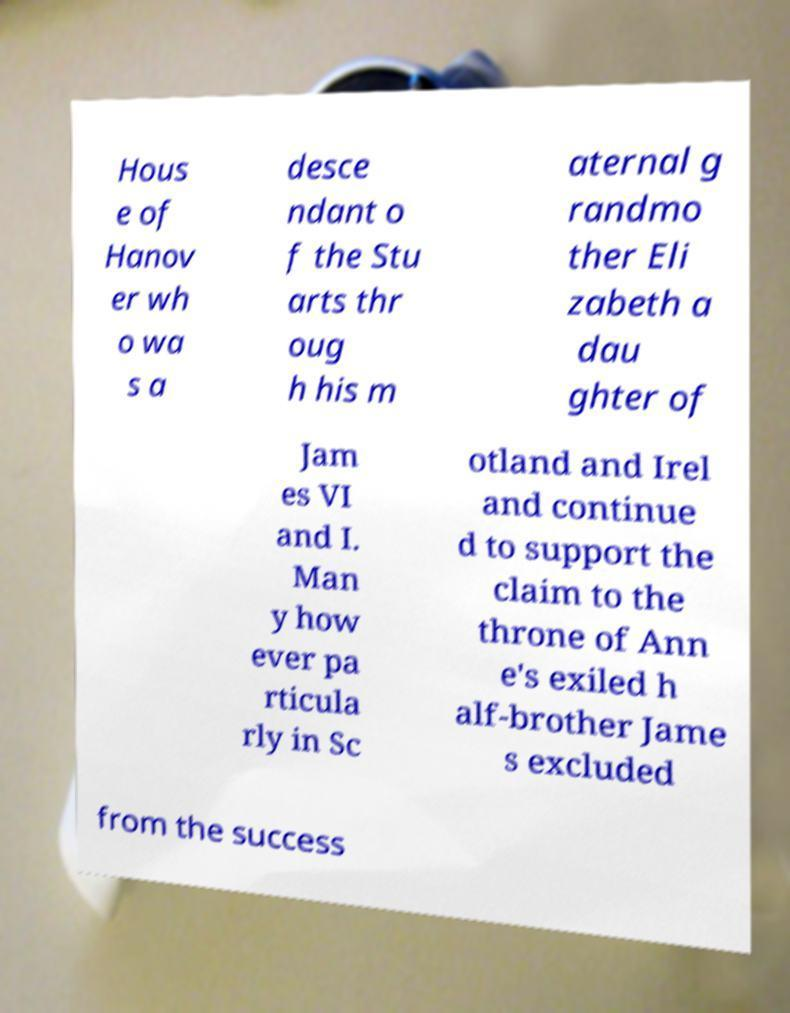I need the written content from this picture converted into text. Can you do that? Hous e of Hanov er wh o wa s a desce ndant o f the Stu arts thr oug h his m aternal g randmo ther Eli zabeth a dau ghter of Jam es VI and I. Man y how ever pa rticula rly in Sc otland and Irel and continue d to support the claim to the throne of Ann e's exiled h alf-brother Jame s excluded from the success 